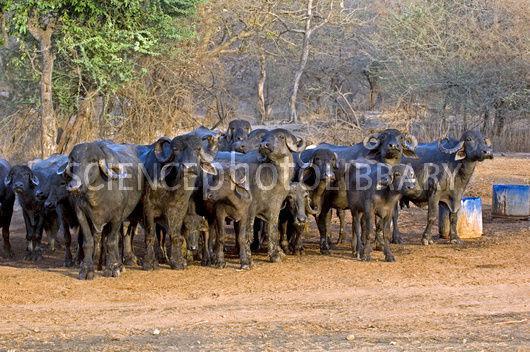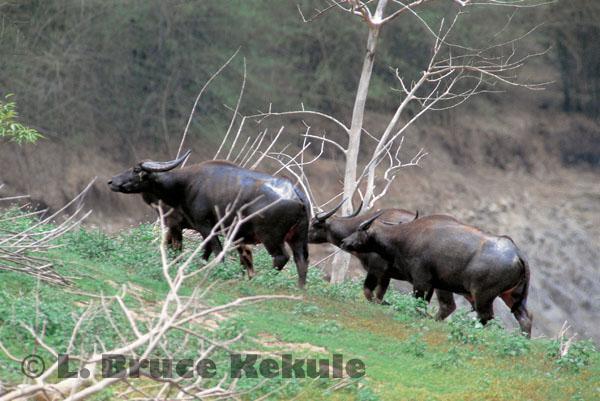The first image is the image on the left, the second image is the image on the right. Examine the images to the left and right. Is the description "Exactly two hooved animals are shown in one image." accurate? Answer yes or no. No. The first image is the image on the left, the second image is the image on the right. Evaluate the accuracy of this statement regarding the images: "One of the images contains exactly two steer". Is it true? Answer yes or no. No. 